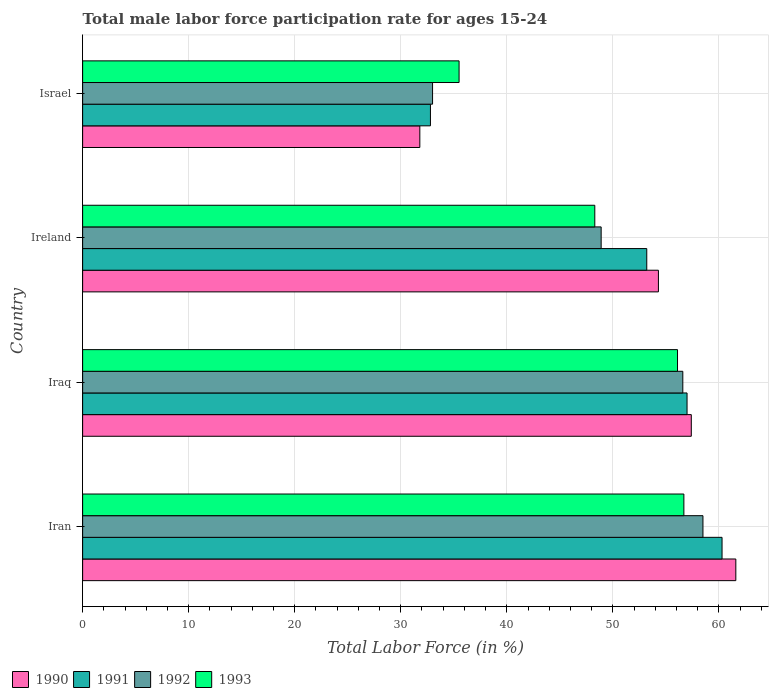Are the number of bars on each tick of the Y-axis equal?
Give a very brief answer. Yes. How many bars are there on the 4th tick from the bottom?
Your answer should be very brief. 4. What is the male labor force participation rate in 1991 in Iraq?
Ensure brevity in your answer.  57. Across all countries, what is the maximum male labor force participation rate in 1993?
Your answer should be very brief. 56.7. Across all countries, what is the minimum male labor force participation rate in 1990?
Provide a short and direct response. 31.8. In which country was the male labor force participation rate in 1993 maximum?
Make the answer very short. Iran. In which country was the male labor force participation rate in 1992 minimum?
Offer a terse response. Israel. What is the total male labor force participation rate in 1993 in the graph?
Offer a terse response. 196.6. What is the difference between the male labor force participation rate in 1993 in Iran and that in Israel?
Offer a very short reply. 21.2. What is the difference between the male labor force participation rate in 1991 in Iran and the male labor force participation rate in 1992 in Iraq?
Offer a terse response. 3.7. What is the average male labor force participation rate in 1990 per country?
Your response must be concise. 51.27. What is the difference between the male labor force participation rate in 1992 and male labor force participation rate in 1990 in Ireland?
Provide a succinct answer. -5.4. In how many countries, is the male labor force participation rate in 1992 greater than 10 %?
Offer a terse response. 4. What is the ratio of the male labor force participation rate in 1991 in Ireland to that in Israel?
Give a very brief answer. 1.62. What is the difference between the highest and the second highest male labor force participation rate in 1991?
Give a very brief answer. 3.3. What is the difference between the highest and the lowest male labor force participation rate in 1991?
Give a very brief answer. 27.5. In how many countries, is the male labor force participation rate in 1992 greater than the average male labor force participation rate in 1992 taken over all countries?
Offer a terse response. 2. Is it the case that in every country, the sum of the male labor force participation rate in 1990 and male labor force participation rate in 1993 is greater than the sum of male labor force participation rate in 1992 and male labor force participation rate in 1991?
Provide a succinct answer. No. What does the 1st bar from the bottom in Ireland represents?
Give a very brief answer. 1990. Is it the case that in every country, the sum of the male labor force participation rate in 1990 and male labor force participation rate in 1991 is greater than the male labor force participation rate in 1993?
Offer a very short reply. Yes. What is the difference between two consecutive major ticks on the X-axis?
Offer a terse response. 10. Are the values on the major ticks of X-axis written in scientific E-notation?
Your answer should be very brief. No. How many legend labels are there?
Your answer should be very brief. 4. What is the title of the graph?
Give a very brief answer. Total male labor force participation rate for ages 15-24. Does "2007" appear as one of the legend labels in the graph?
Your response must be concise. No. What is the Total Labor Force (in %) of 1990 in Iran?
Your answer should be compact. 61.6. What is the Total Labor Force (in %) of 1991 in Iran?
Provide a succinct answer. 60.3. What is the Total Labor Force (in %) of 1992 in Iran?
Offer a very short reply. 58.5. What is the Total Labor Force (in %) of 1993 in Iran?
Your answer should be compact. 56.7. What is the Total Labor Force (in %) in 1990 in Iraq?
Give a very brief answer. 57.4. What is the Total Labor Force (in %) of 1992 in Iraq?
Make the answer very short. 56.6. What is the Total Labor Force (in %) in 1993 in Iraq?
Provide a succinct answer. 56.1. What is the Total Labor Force (in %) of 1990 in Ireland?
Your answer should be compact. 54.3. What is the Total Labor Force (in %) of 1991 in Ireland?
Offer a very short reply. 53.2. What is the Total Labor Force (in %) of 1992 in Ireland?
Provide a succinct answer. 48.9. What is the Total Labor Force (in %) of 1993 in Ireland?
Ensure brevity in your answer.  48.3. What is the Total Labor Force (in %) in 1990 in Israel?
Make the answer very short. 31.8. What is the Total Labor Force (in %) of 1991 in Israel?
Make the answer very short. 32.8. What is the Total Labor Force (in %) in 1992 in Israel?
Your answer should be compact. 33. What is the Total Labor Force (in %) of 1993 in Israel?
Your answer should be very brief. 35.5. Across all countries, what is the maximum Total Labor Force (in %) of 1990?
Your answer should be very brief. 61.6. Across all countries, what is the maximum Total Labor Force (in %) in 1991?
Ensure brevity in your answer.  60.3. Across all countries, what is the maximum Total Labor Force (in %) of 1992?
Offer a very short reply. 58.5. Across all countries, what is the maximum Total Labor Force (in %) of 1993?
Offer a terse response. 56.7. Across all countries, what is the minimum Total Labor Force (in %) of 1990?
Your answer should be compact. 31.8. Across all countries, what is the minimum Total Labor Force (in %) in 1991?
Keep it short and to the point. 32.8. Across all countries, what is the minimum Total Labor Force (in %) in 1993?
Your answer should be compact. 35.5. What is the total Total Labor Force (in %) in 1990 in the graph?
Keep it short and to the point. 205.1. What is the total Total Labor Force (in %) in 1991 in the graph?
Your answer should be very brief. 203.3. What is the total Total Labor Force (in %) in 1992 in the graph?
Offer a very short reply. 197. What is the total Total Labor Force (in %) of 1993 in the graph?
Offer a very short reply. 196.6. What is the difference between the Total Labor Force (in %) in 1991 in Iran and that in Ireland?
Your response must be concise. 7.1. What is the difference between the Total Labor Force (in %) in 1990 in Iran and that in Israel?
Ensure brevity in your answer.  29.8. What is the difference between the Total Labor Force (in %) in 1993 in Iran and that in Israel?
Provide a succinct answer. 21.2. What is the difference between the Total Labor Force (in %) of 1990 in Iraq and that in Ireland?
Your answer should be very brief. 3.1. What is the difference between the Total Labor Force (in %) of 1991 in Iraq and that in Ireland?
Your response must be concise. 3.8. What is the difference between the Total Labor Force (in %) in 1990 in Iraq and that in Israel?
Offer a terse response. 25.6. What is the difference between the Total Labor Force (in %) of 1991 in Iraq and that in Israel?
Give a very brief answer. 24.2. What is the difference between the Total Labor Force (in %) of 1992 in Iraq and that in Israel?
Your response must be concise. 23.6. What is the difference between the Total Labor Force (in %) in 1993 in Iraq and that in Israel?
Keep it short and to the point. 20.6. What is the difference between the Total Labor Force (in %) of 1991 in Ireland and that in Israel?
Your answer should be very brief. 20.4. What is the difference between the Total Labor Force (in %) of 1993 in Ireland and that in Israel?
Give a very brief answer. 12.8. What is the difference between the Total Labor Force (in %) in 1990 in Iran and the Total Labor Force (in %) in 1992 in Iraq?
Your answer should be compact. 5. What is the difference between the Total Labor Force (in %) of 1990 in Iran and the Total Labor Force (in %) of 1993 in Iraq?
Keep it short and to the point. 5.5. What is the difference between the Total Labor Force (in %) of 1990 in Iran and the Total Labor Force (in %) of 1993 in Ireland?
Provide a short and direct response. 13.3. What is the difference between the Total Labor Force (in %) of 1991 in Iran and the Total Labor Force (in %) of 1992 in Ireland?
Make the answer very short. 11.4. What is the difference between the Total Labor Force (in %) in 1990 in Iran and the Total Labor Force (in %) in 1991 in Israel?
Your answer should be very brief. 28.8. What is the difference between the Total Labor Force (in %) in 1990 in Iran and the Total Labor Force (in %) in 1992 in Israel?
Your answer should be very brief. 28.6. What is the difference between the Total Labor Force (in %) of 1990 in Iran and the Total Labor Force (in %) of 1993 in Israel?
Make the answer very short. 26.1. What is the difference between the Total Labor Force (in %) in 1991 in Iran and the Total Labor Force (in %) in 1992 in Israel?
Your answer should be very brief. 27.3. What is the difference between the Total Labor Force (in %) of 1991 in Iran and the Total Labor Force (in %) of 1993 in Israel?
Offer a terse response. 24.8. What is the difference between the Total Labor Force (in %) in 1992 in Iran and the Total Labor Force (in %) in 1993 in Israel?
Keep it short and to the point. 23. What is the difference between the Total Labor Force (in %) of 1990 in Iraq and the Total Labor Force (in %) of 1992 in Ireland?
Give a very brief answer. 8.5. What is the difference between the Total Labor Force (in %) of 1991 in Iraq and the Total Labor Force (in %) of 1992 in Ireland?
Your answer should be compact. 8.1. What is the difference between the Total Labor Force (in %) in 1991 in Iraq and the Total Labor Force (in %) in 1993 in Ireland?
Provide a short and direct response. 8.7. What is the difference between the Total Labor Force (in %) in 1990 in Iraq and the Total Labor Force (in %) in 1991 in Israel?
Your answer should be very brief. 24.6. What is the difference between the Total Labor Force (in %) of 1990 in Iraq and the Total Labor Force (in %) of 1992 in Israel?
Give a very brief answer. 24.4. What is the difference between the Total Labor Force (in %) of 1990 in Iraq and the Total Labor Force (in %) of 1993 in Israel?
Your answer should be very brief. 21.9. What is the difference between the Total Labor Force (in %) of 1992 in Iraq and the Total Labor Force (in %) of 1993 in Israel?
Your answer should be very brief. 21.1. What is the difference between the Total Labor Force (in %) of 1990 in Ireland and the Total Labor Force (in %) of 1991 in Israel?
Make the answer very short. 21.5. What is the difference between the Total Labor Force (in %) of 1990 in Ireland and the Total Labor Force (in %) of 1992 in Israel?
Provide a short and direct response. 21.3. What is the difference between the Total Labor Force (in %) of 1991 in Ireland and the Total Labor Force (in %) of 1992 in Israel?
Provide a succinct answer. 20.2. What is the difference between the Total Labor Force (in %) of 1991 in Ireland and the Total Labor Force (in %) of 1993 in Israel?
Offer a terse response. 17.7. What is the difference between the Total Labor Force (in %) of 1992 in Ireland and the Total Labor Force (in %) of 1993 in Israel?
Your answer should be very brief. 13.4. What is the average Total Labor Force (in %) in 1990 per country?
Give a very brief answer. 51.27. What is the average Total Labor Force (in %) in 1991 per country?
Your answer should be compact. 50.83. What is the average Total Labor Force (in %) of 1992 per country?
Make the answer very short. 49.25. What is the average Total Labor Force (in %) of 1993 per country?
Provide a succinct answer. 49.15. What is the difference between the Total Labor Force (in %) in 1990 and Total Labor Force (in %) in 1992 in Iran?
Give a very brief answer. 3.1. What is the difference between the Total Labor Force (in %) of 1990 and Total Labor Force (in %) of 1993 in Iran?
Make the answer very short. 4.9. What is the difference between the Total Labor Force (in %) in 1991 and Total Labor Force (in %) in 1992 in Iran?
Your answer should be compact. 1.8. What is the difference between the Total Labor Force (in %) of 1992 and Total Labor Force (in %) of 1993 in Iran?
Your answer should be compact. 1.8. What is the difference between the Total Labor Force (in %) in 1990 and Total Labor Force (in %) in 1991 in Iraq?
Make the answer very short. 0.4. What is the difference between the Total Labor Force (in %) in 1990 and Total Labor Force (in %) in 1992 in Iraq?
Offer a terse response. 0.8. What is the difference between the Total Labor Force (in %) in 1990 and Total Labor Force (in %) in 1993 in Iraq?
Offer a terse response. 1.3. What is the difference between the Total Labor Force (in %) of 1991 and Total Labor Force (in %) of 1992 in Iraq?
Your response must be concise. 0.4. What is the difference between the Total Labor Force (in %) in 1992 and Total Labor Force (in %) in 1993 in Iraq?
Your response must be concise. 0.5. What is the difference between the Total Labor Force (in %) of 1990 and Total Labor Force (in %) of 1991 in Ireland?
Provide a succinct answer. 1.1. What is the difference between the Total Labor Force (in %) in 1990 and Total Labor Force (in %) in 1992 in Ireland?
Make the answer very short. 5.4. What is the difference between the Total Labor Force (in %) of 1991 and Total Labor Force (in %) of 1992 in Ireland?
Give a very brief answer. 4.3. What is the difference between the Total Labor Force (in %) in 1991 and Total Labor Force (in %) in 1993 in Ireland?
Your answer should be very brief. 4.9. What is the difference between the Total Labor Force (in %) of 1992 and Total Labor Force (in %) of 1993 in Ireland?
Provide a short and direct response. 0.6. What is the difference between the Total Labor Force (in %) of 1990 and Total Labor Force (in %) of 1991 in Israel?
Provide a succinct answer. -1. What is the difference between the Total Labor Force (in %) of 1990 and Total Labor Force (in %) of 1992 in Israel?
Your answer should be very brief. -1.2. What is the difference between the Total Labor Force (in %) of 1990 and Total Labor Force (in %) of 1993 in Israel?
Your response must be concise. -3.7. What is the difference between the Total Labor Force (in %) of 1991 and Total Labor Force (in %) of 1992 in Israel?
Your response must be concise. -0.2. What is the difference between the Total Labor Force (in %) of 1992 and Total Labor Force (in %) of 1993 in Israel?
Keep it short and to the point. -2.5. What is the ratio of the Total Labor Force (in %) in 1990 in Iran to that in Iraq?
Offer a very short reply. 1.07. What is the ratio of the Total Labor Force (in %) of 1991 in Iran to that in Iraq?
Ensure brevity in your answer.  1.06. What is the ratio of the Total Labor Force (in %) of 1992 in Iran to that in Iraq?
Offer a terse response. 1.03. What is the ratio of the Total Labor Force (in %) in 1993 in Iran to that in Iraq?
Offer a very short reply. 1.01. What is the ratio of the Total Labor Force (in %) of 1990 in Iran to that in Ireland?
Provide a short and direct response. 1.13. What is the ratio of the Total Labor Force (in %) in 1991 in Iran to that in Ireland?
Provide a succinct answer. 1.13. What is the ratio of the Total Labor Force (in %) of 1992 in Iran to that in Ireland?
Your answer should be very brief. 1.2. What is the ratio of the Total Labor Force (in %) in 1993 in Iran to that in Ireland?
Ensure brevity in your answer.  1.17. What is the ratio of the Total Labor Force (in %) of 1990 in Iran to that in Israel?
Give a very brief answer. 1.94. What is the ratio of the Total Labor Force (in %) of 1991 in Iran to that in Israel?
Give a very brief answer. 1.84. What is the ratio of the Total Labor Force (in %) in 1992 in Iran to that in Israel?
Your answer should be compact. 1.77. What is the ratio of the Total Labor Force (in %) in 1993 in Iran to that in Israel?
Make the answer very short. 1.6. What is the ratio of the Total Labor Force (in %) of 1990 in Iraq to that in Ireland?
Make the answer very short. 1.06. What is the ratio of the Total Labor Force (in %) of 1991 in Iraq to that in Ireland?
Provide a succinct answer. 1.07. What is the ratio of the Total Labor Force (in %) of 1992 in Iraq to that in Ireland?
Offer a terse response. 1.16. What is the ratio of the Total Labor Force (in %) in 1993 in Iraq to that in Ireland?
Provide a succinct answer. 1.16. What is the ratio of the Total Labor Force (in %) of 1990 in Iraq to that in Israel?
Offer a very short reply. 1.8. What is the ratio of the Total Labor Force (in %) in 1991 in Iraq to that in Israel?
Offer a very short reply. 1.74. What is the ratio of the Total Labor Force (in %) in 1992 in Iraq to that in Israel?
Give a very brief answer. 1.72. What is the ratio of the Total Labor Force (in %) in 1993 in Iraq to that in Israel?
Your answer should be very brief. 1.58. What is the ratio of the Total Labor Force (in %) of 1990 in Ireland to that in Israel?
Your response must be concise. 1.71. What is the ratio of the Total Labor Force (in %) of 1991 in Ireland to that in Israel?
Your answer should be very brief. 1.62. What is the ratio of the Total Labor Force (in %) in 1992 in Ireland to that in Israel?
Make the answer very short. 1.48. What is the ratio of the Total Labor Force (in %) in 1993 in Ireland to that in Israel?
Make the answer very short. 1.36. What is the difference between the highest and the lowest Total Labor Force (in %) of 1990?
Provide a short and direct response. 29.8. What is the difference between the highest and the lowest Total Labor Force (in %) in 1993?
Give a very brief answer. 21.2. 